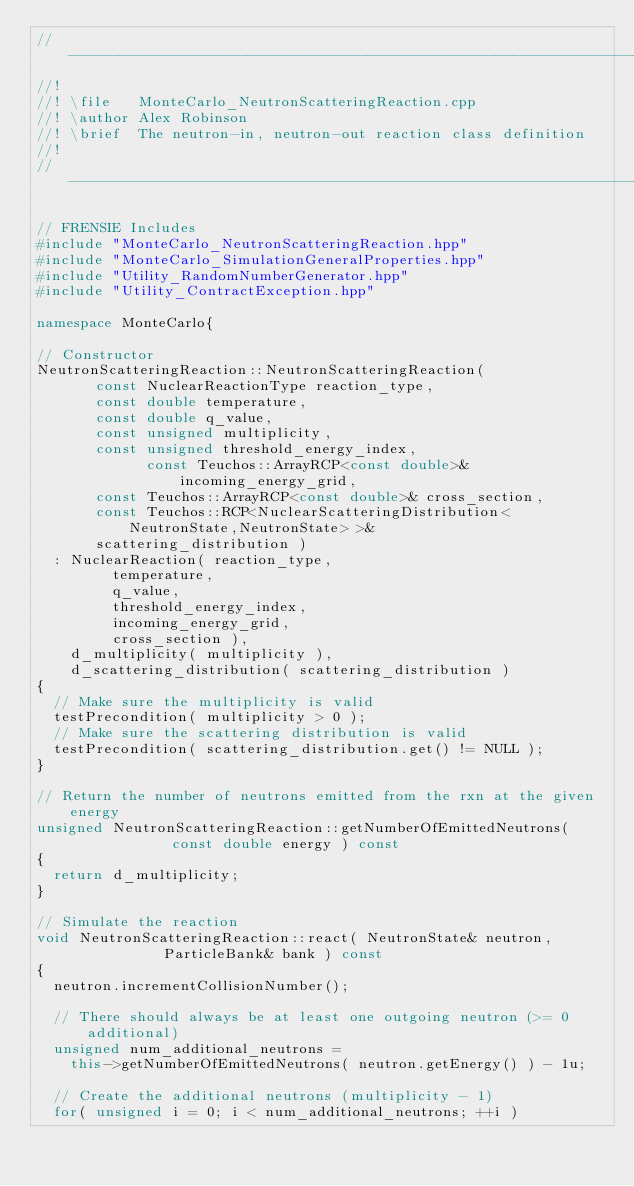Convert code to text. <code><loc_0><loc_0><loc_500><loc_500><_C++_>//---------------------------------------------------------------------------//
//!
//! \file   MonteCarlo_NeutronScatteringReaction.cpp
//! \author Alex Robinson
//! \brief  The neutron-in, neutron-out reaction class definition
//!
//---------------------------------------------------------------------------//

// FRENSIE Includes
#include "MonteCarlo_NeutronScatteringReaction.hpp"
#include "MonteCarlo_SimulationGeneralProperties.hpp"
#include "Utility_RandomNumberGenerator.hpp"
#include "Utility_ContractException.hpp"

namespace MonteCarlo{

// Constructor 
NeutronScatteringReaction::NeutronScatteringReaction( 
		   const NuclearReactionType reaction_type,
		   const double temperature,
		   const double q_value,
		   const unsigned multiplicity,
		   const unsigned threshold_energy_index,
	           const Teuchos::ArrayRCP<const double>& incoming_energy_grid,
		   const Teuchos::ArrayRCP<const double>& cross_section,
		   const Teuchos::RCP<NuclearScatteringDistribution<NeutronState,NeutronState> >& 
		   scattering_distribution )
  : NuclearReaction( reaction_type, 
		     temperature, 
		     q_value,
		     threshold_energy_index,
		     incoming_energy_grid,
		     cross_section ),
    d_multiplicity( multiplicity ),
    d_scattering_distribution( scattering_distribution )
{
  // Make sure the multiplicity is valid
  testPrecondition( multiplicity > 0 );
  // Make sure the scattering distribution is valid
  testPrecondition( scattering_distribution.get() != NULL );
}

// Return the number of neutrons emitted from the rxn at the given energy
unsigned NeutronScatteringReaction::getNumberOfEmittedNeutrons(
						    const double energy ) const
{
  return d_multiplicity;
}

// Simulate the reaction
void NeutronScatteringReaction::react( NeutronState& neutron, 
				       ParticleBank& bank ) const
{
  neutron.incrementCollisionNumber();
  
  // There should always be at least one outgoing neutron (>= 0 additional)
  unsigned num_additional_neutrons = 
    this->getNumberOfEmittedNeutrons( neutron.getEnergy() ) - 1u;

  // Create the additional neutrons (multiplicity - 1)
  for( unsigned i = 0; i < num_additional_neutrons; ++i )</code> 